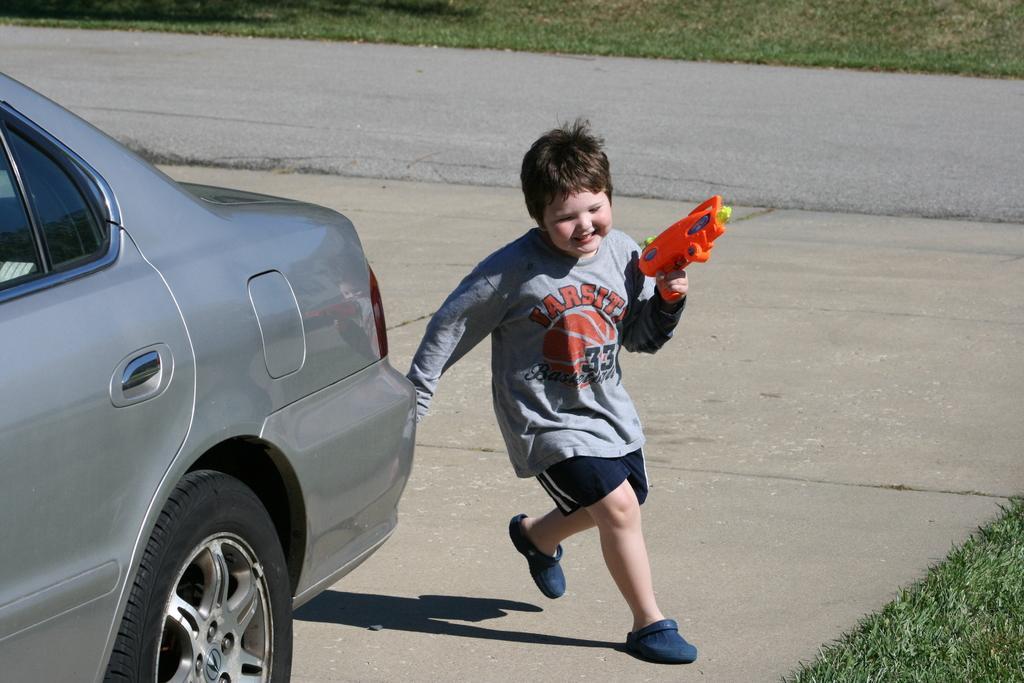In one or two sentences, can you explain what this image depicts? In this picture there is a boy who is wearing t-shirt, short and shoe. He is holding a plastic gun. Beside him there is a grey car. At the top I can see the road and grass. 